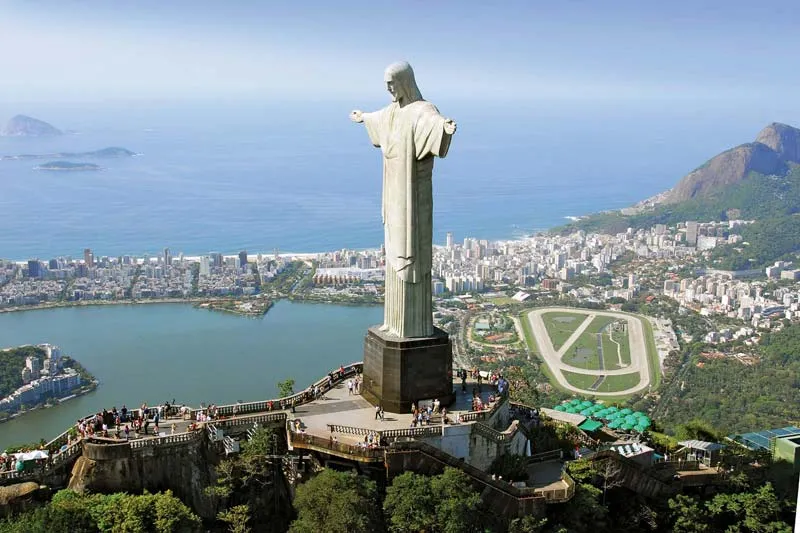Can you describe the main features of this image for me? The image offers a magnificent view of the Christ the Redeemer statue, or Cristo Redentor, in Rio de Janeiro, Brazil. This iconic symbol, sculpted in Art Deco style, stands approximately 30 meters tall, not including its 8-meter pedestal, and its arms stretch 28 meters wide. The statue is positioned atop the Corcovado mountain, 700 meters above sea level, providing a panoramic backdrop that encompasses the sprawling urban landscape, lush greenery, and the expansive Atlantic Ocean. Below the statue, the viewing platform teems with visitors, underscoring the statue's popularity and cultural significance as both a religious symbol and a tourist attraction. The overall composition of the image conveys a narrative of inspiration and introspection, set against the vibrant life of one of the world's most enchanting cities. 